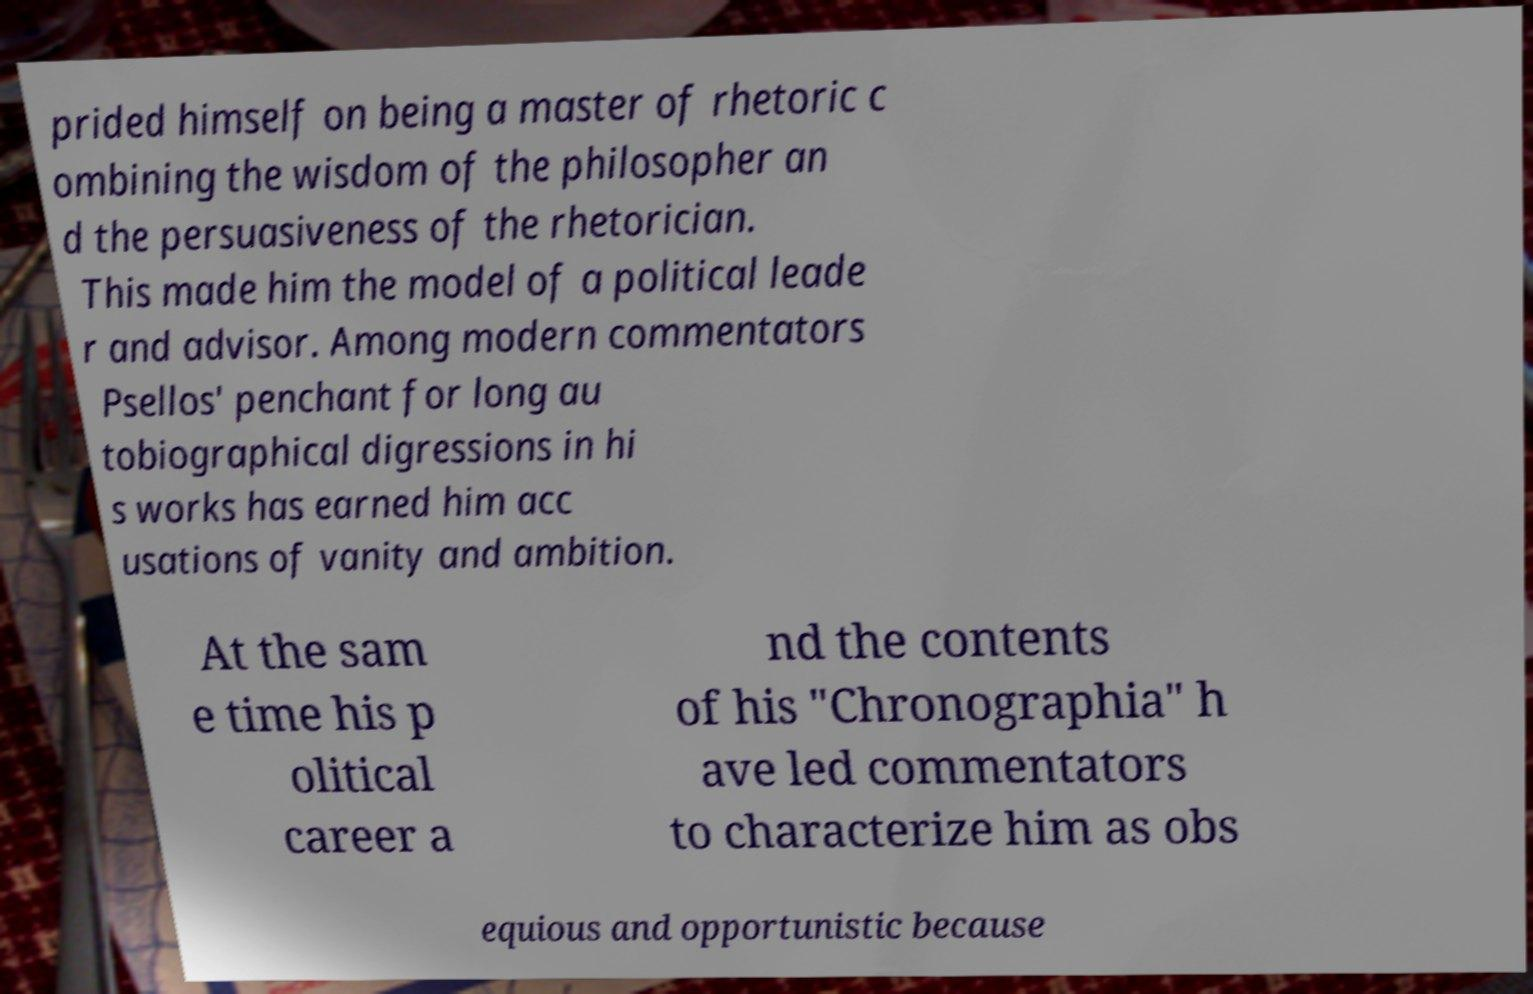Can you read and provide the text displayed in the image?This photo seems to have some interesting text. Can you extract and type it out for me? prided himself on being a master of rhetoric c ombining the wisdom of the philosopher an d the persuasiveness of the rhetorician. This made him the model of a political leade r and advisor. Among modern commentators Psellos' penchant for long au tobiographical digressions in hi s works has earned him acc usations of vanity and ambition. At the sam e time his p olitical career a nd the contents of his "Chronographia" h ave led commentators to characterize him as obs equious and opportunistic because 